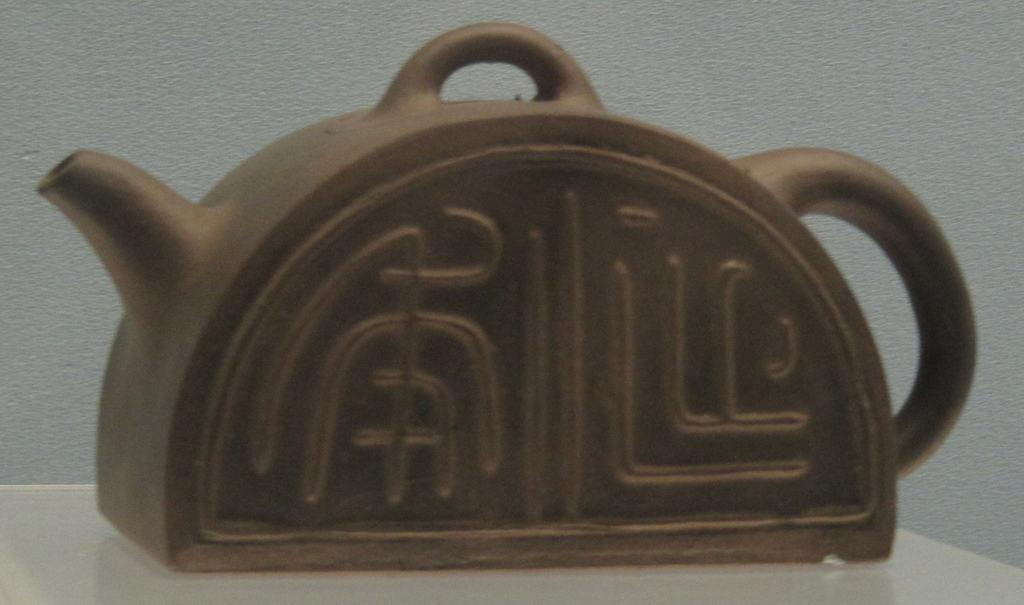What object is placed on the table in the image? There is a kettle placed on a table in the image. What can be seen in the background of the image? There is a wall in the background of the image. What type of soup is being prepared in the kettle in the image? There is no soup or indication of cooking in the image; it only shows a kettle placed on a table. 